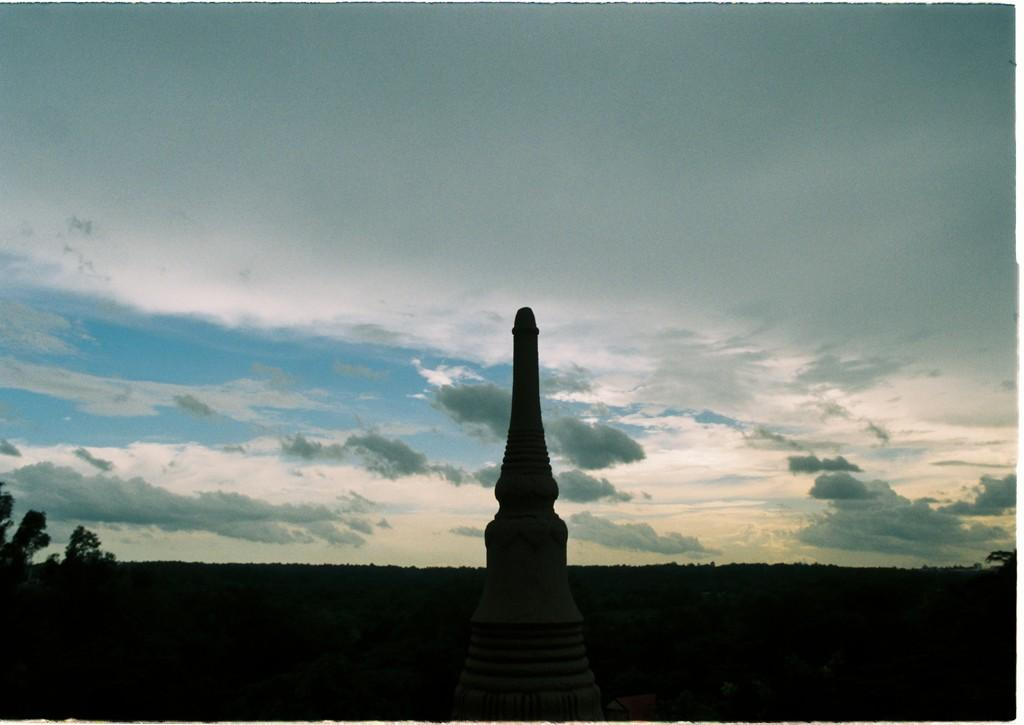What can be seen in the sky in the image? The sky with clouds is visible in the image. What structure is present in the image? There is a tower in the image. What type of vegetation is in the image? Trees are present in the image. Reasoning: Let' Let's think step by step in order to produce the conversation. We start by identifying the main elements in the image, which are the sky, clouds, tower, and trees. Then, we formulate questions that focus on each of these elements, ensuring that each question can be answered definitively with the information given. We avoid yes/no questions and ensure that the language is simple and clear. Absurd Question/Answer: What type of lumber is being used to construct the frame of the tower in the image? There is no mention of lumber or a frame in the image; it only shows a tower and trees. What type of clouds can be seen in the image? The provided facts only mention that there are clouds in the sky, but they do not specify the type of clouds. --- Facts: 1. There is a person sitting on a bench in the image. 2. The person is reading a book. 3. There is a tree behind the bench. 4. The ground is visible in the image. Absurd Topics: bicycle, ocean, parrot Conversation: What is the person in the image doing? The person is sitting on a bench and reading a book in the image. What can be seen behind the bench? There is a tree behind the bench in the image. What is visible on the ground in the image? The ground is visible in the image. Reasoning: Let's think step by step in order to produce the conversation. We start by identifying the main subject in the image, which is the person sitting on the bench. Then, we expand the conversation to include the person's activity (reading a book) and the surrounding environment (tree and ground). Each question is designed to elicit a specific detail about the image that is known from the provided facts. Absurd Question/Answer: 